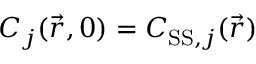Convert formula to latex. <formula><loc_0><loc_0><loc_500><loc_500>C _ { j } ( \vec { r } , 0 ) = C _ { S S , j } ( \vec { r } )</formula> 